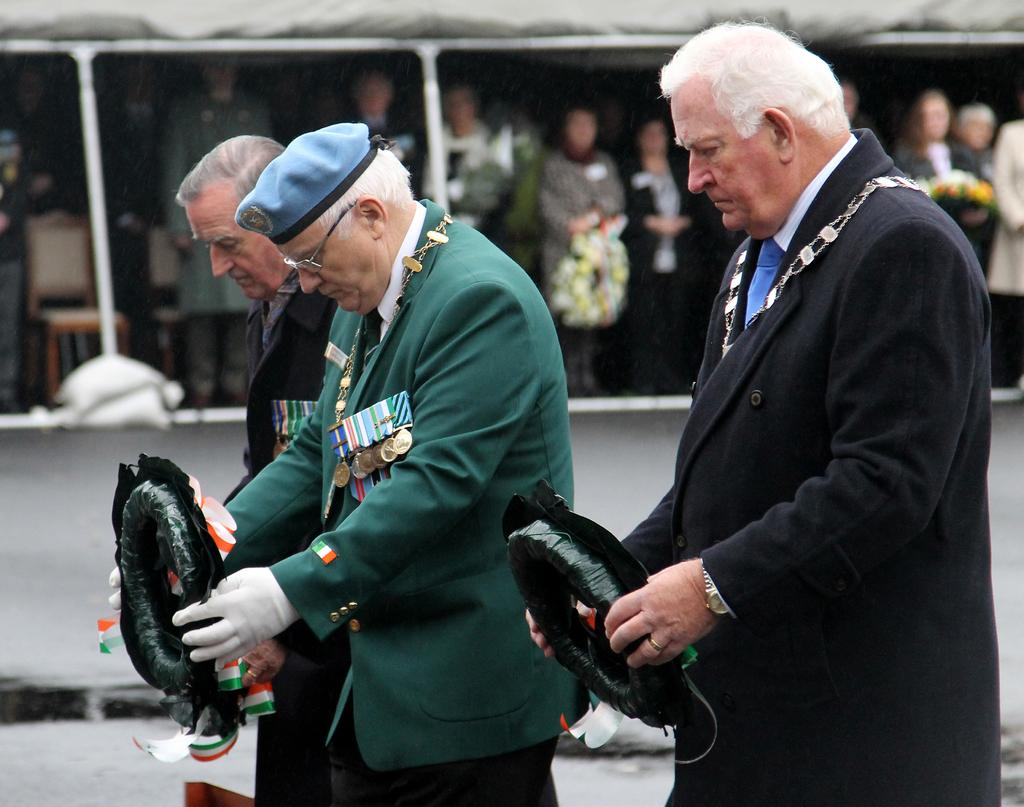What is happening in the image? There are people standing in the image, and they are holding objects. Can you describe the setting where the people are located? There are many people under a tent, and they are also holding objects in their hands. What type of canvas is being used to create the example of a screw in the image? There is no canvas, example, or screw present in the image. 